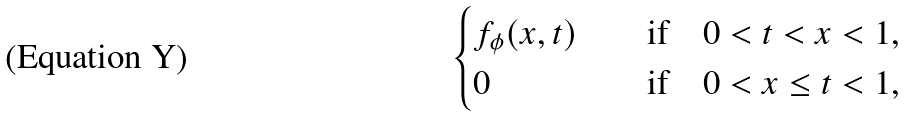Convert formula to latex. <formula><loc_0><loc_0><loc_500><loc_500>\begin{cases} f _ { \phi } ( x , t ) & \quad \text {if} \quad 0 < t < x < 1 , \\ 0 & \quad \text {if} \quad 0 < x \leq t < 1 , \end{cases}</formula> 